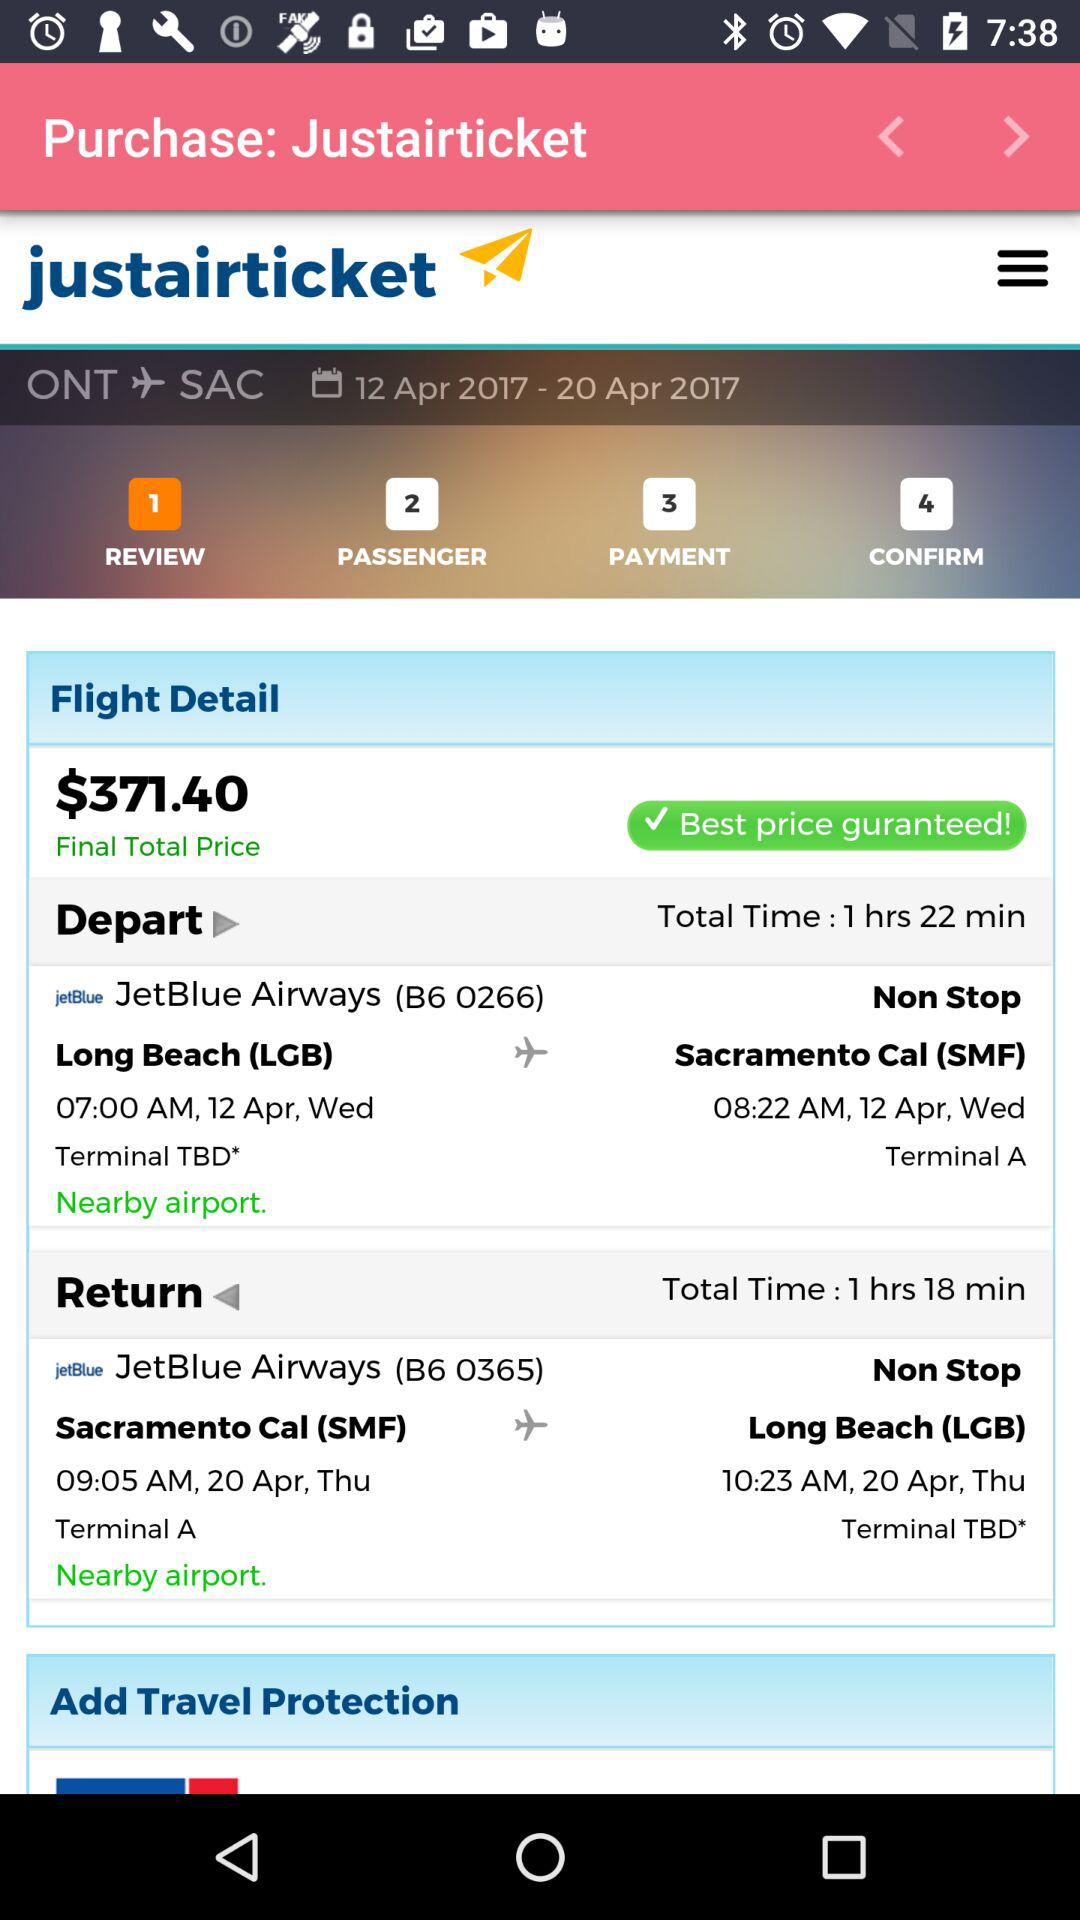What is the airway's departure location? The airway's departure location is Long Beach (LGB). 